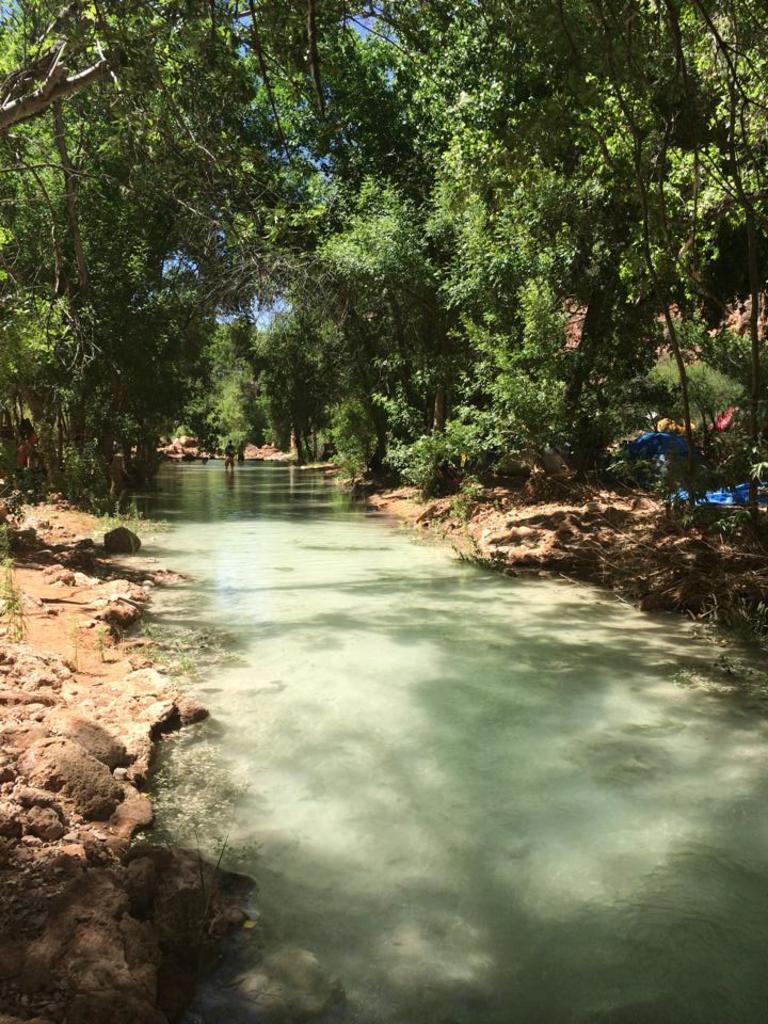Please provide a concise description of this image. In this image we can see a person in the water, there are some trees, tents and stones, also we can see the sky. 